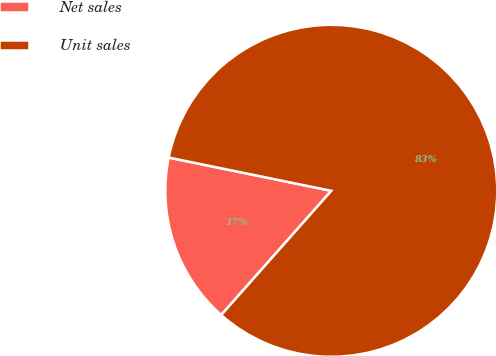Convert chart. <chart><loc_0><loc_0><loc_500><loc_500><pie_chart><fcel>Net sales<fcel>Unit sales<nl><fcel>16.67%<fcel>83.33%<nl></chart> 